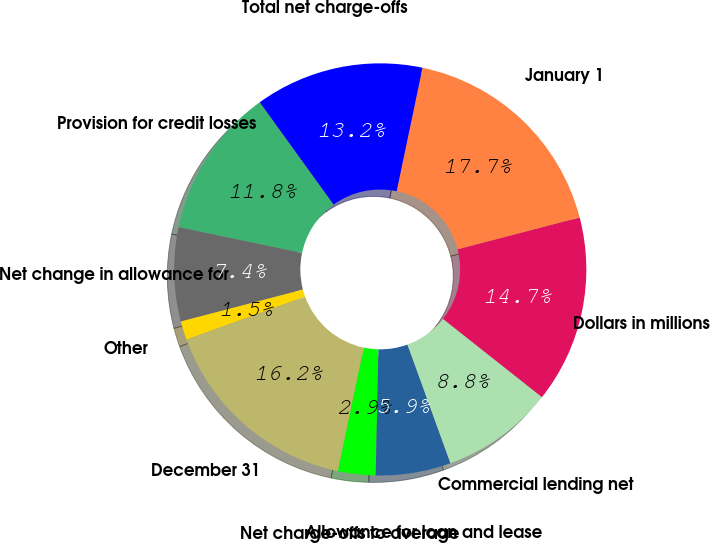<chart> <loc_0><loc_0><loc_500><loc_500><pie_chart><fcel>Dollars in millions<fcel>January 1<fcel>Total net charge-offs<fcel>Provision for credit losses<fcel>Net change in allowance for<fcel>Other<fcel>December 31<fcel>Net charge-offs to average<fcel>Allowance for loan and lease<fcel>Commercial lending net<nl><fcel>14.7%<fcel>17.65%<fcel>13.23%<fcel>11.76%<fcel>7.35%<fcel>1.47%<fcel>16.17%<fcel>2.94%<fcel>5.88%<fcel>8.82%<nl></chart> 